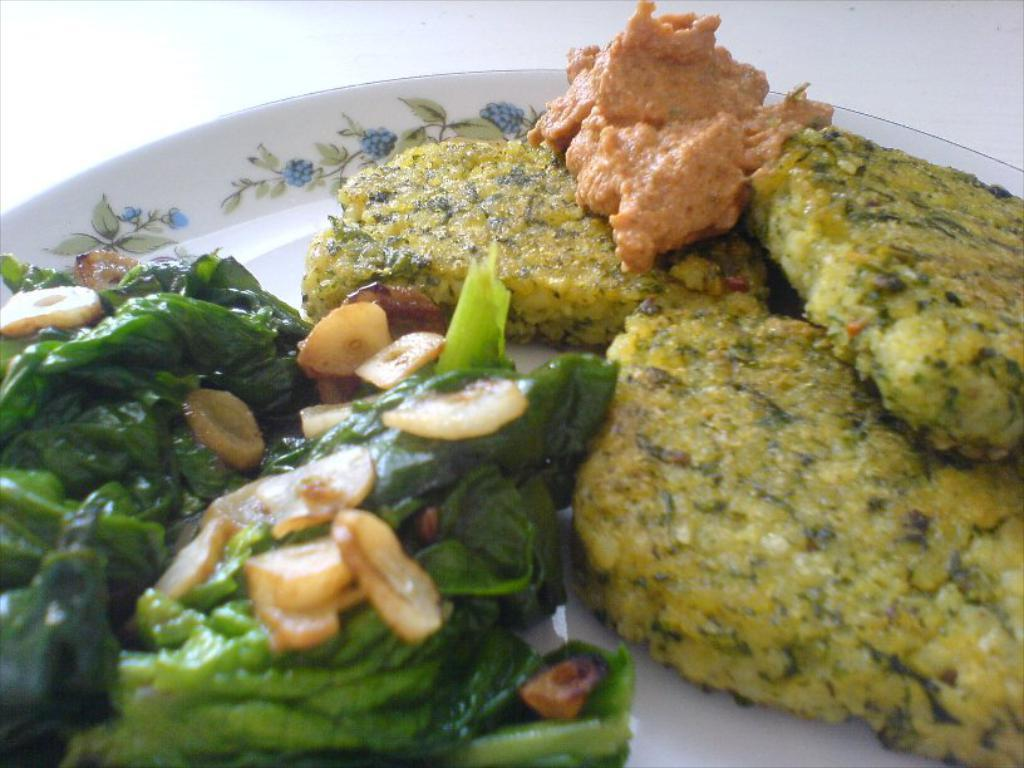What object is located in the center of the image? There is a plate in the center of the image. What is on the plate in the image? Food is placed on the plate in the image. How many toes can be seen on the hill in the image? There are no toes or hills present in the image; it features a plate with food. 